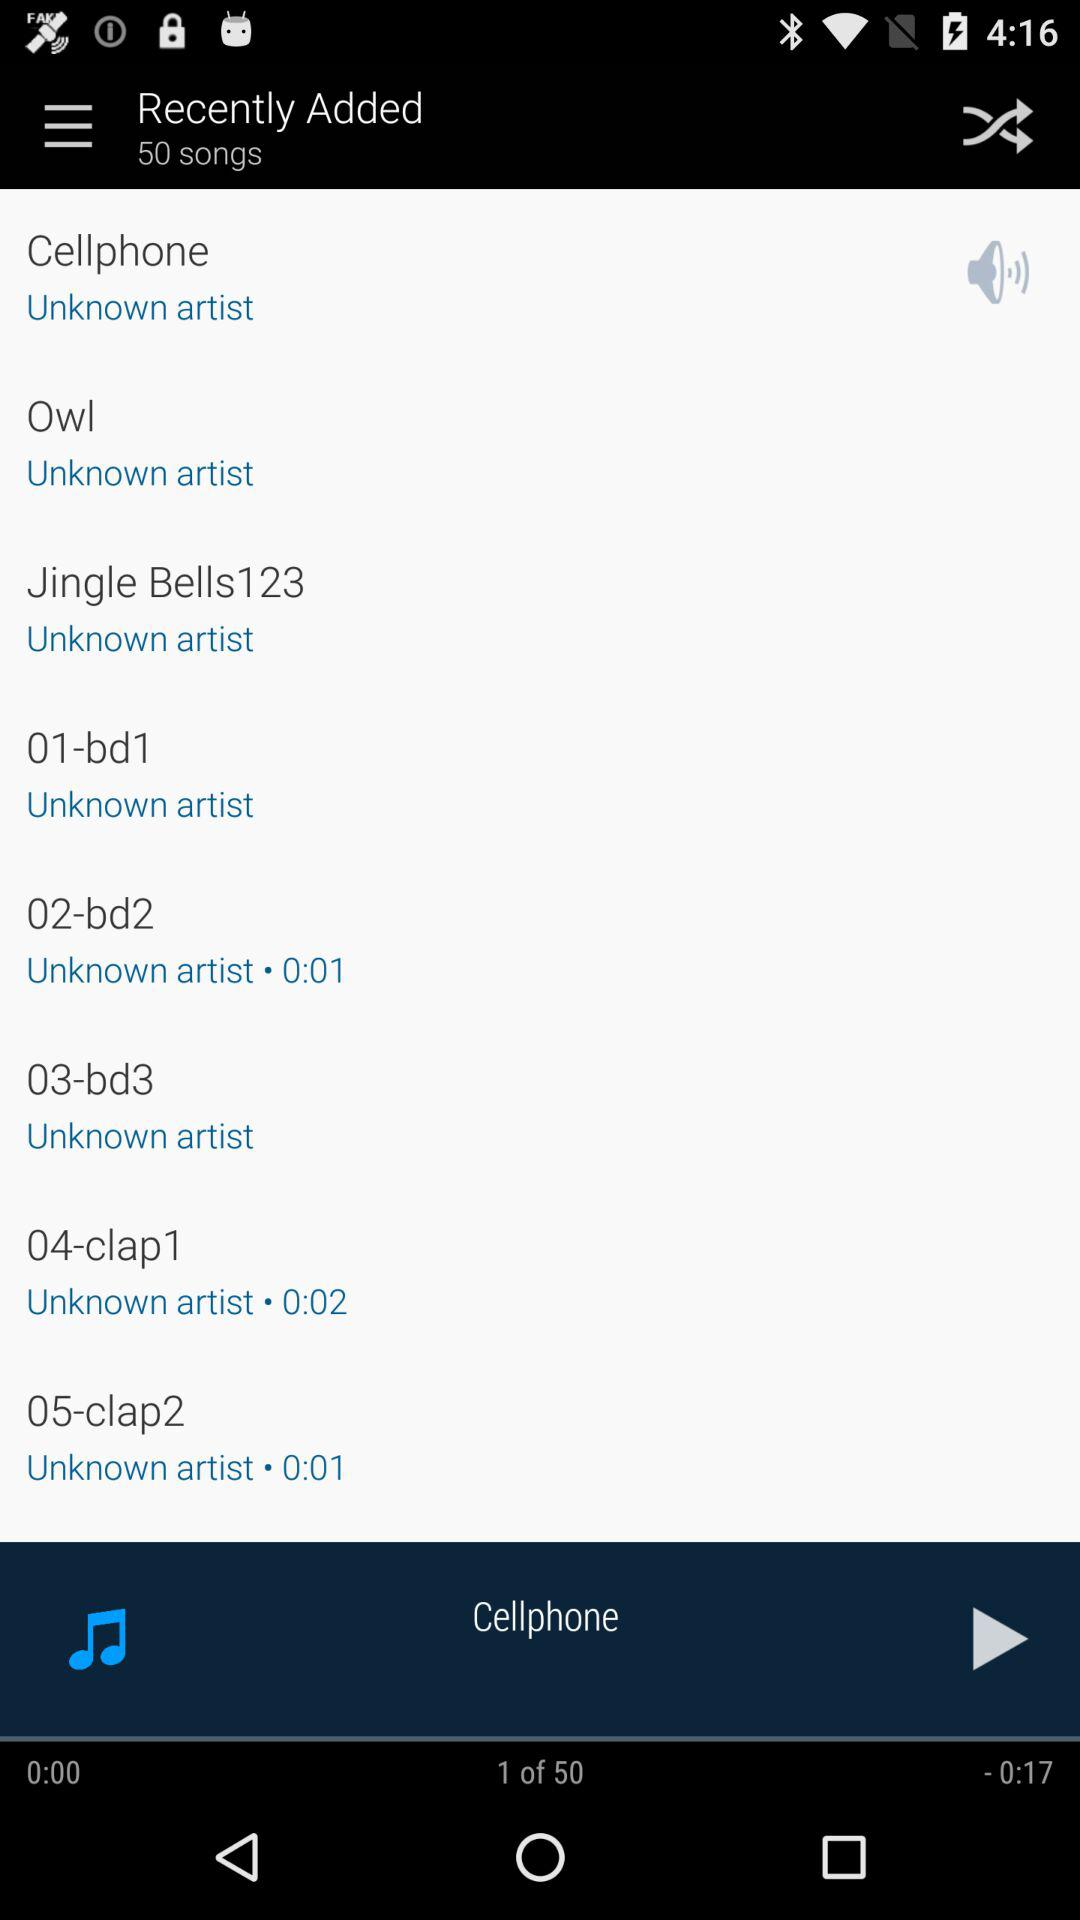How many songs have a duration of less than 1 second?
Answer the question using a single word or phrase. 2 